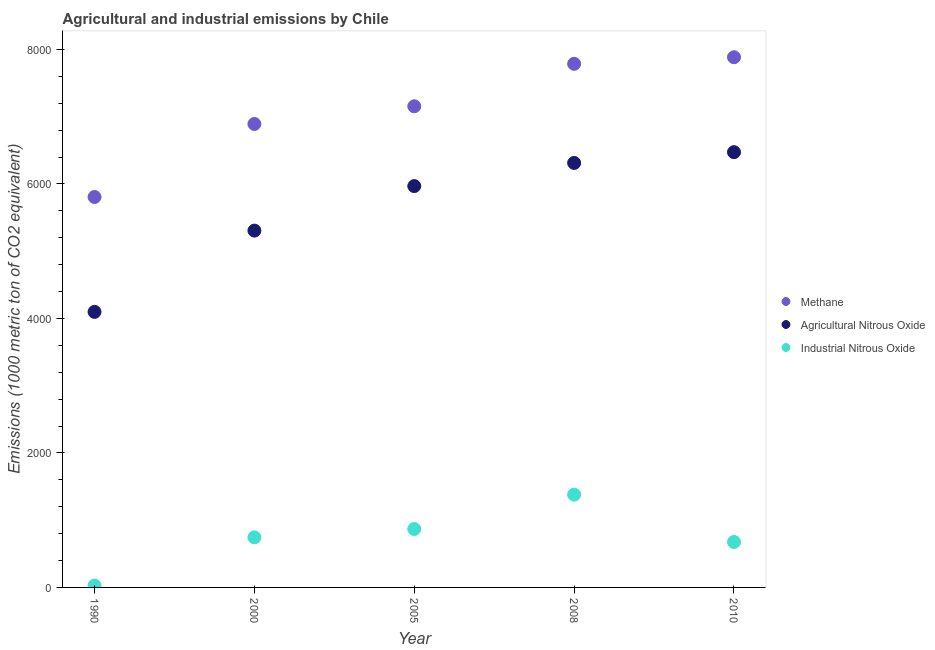What is the amount of agricultural nitrous oxide emissions in 1990?
Provide a short and direct response. 4097. Across all years, what is the maximum amount of methane emissions?
Provide a succinct answer. 7883.7. Across all years, what is the minimum amount of methane emissions?
Your answer should be compact. 5805.8. In which year was the amount of agricultural nitrous oxide emissions minimum?
Offer a very short reply. 1990. What is the total amount of industrial nitrous oxide emissions in the graph?
Ensure brevity in your answer.  3697.6. What is the difference between the amount of methane emissions in 1990 and that in 2005?
Keep it short and to the point. -1348.7. What is the difference between the amount of agricultural nitrous oxide emissions in 2010 and the amount of industrial nitrous oxide emissions in 2005?
Provide a short and direct response. 5603.4. What is the average amount of methane emissions per year?
Make the answer very short. 7104.34. In the year 2005, what is the difference between the amount of agricultural nitrous oxide emissions and amount of industrial nitrous oxide emissions?
Your answer should be very brief. 5099. What is the ratio of the amount of industrial nitrous oxide emissions in 1990 to that in 2008?
Your response must be concise. 0.02. Is the amount of methane emissions in 1990 less than that in 2010?
Your answer should be very brief. Yes. Is the difference between the amount of industrial nitrous oxide emissions in 2005 and 2008 greater than the difference between the amount of methane emissions in 2005 and 2008?
Make the answer very short. Yes. What is the difference between the highest and the second highest amount of industrial nitrous oxide emissions?
Make the answer very short. 510.9. What is the difference between the highest and the lowest amount of industrial nitrous oxide emissions?
Keep it short and to the point. 1351.8. In how many years, is the amount of methane emissions greater than the average amount of methane emissions taken over all years?
Offer a very short reply. 3. Is the sum of the amount of industrial nitrous oxide emissions in 1990 and 2008 greater than the maximum amount of agricultural nitrous oxide emissions across all years?
Your answer should be very brief. No. Is the amount of agricultural nitrous oxide emissions strictly greater than the amount of industrial nitrous oxide emissions over the years?
Your response must be concise. Yes. How many dotlines are there?
Offer a very short reply. 3. What is the difference between two consecutive major ticks on the Y-axis?
Offer a very short reply. 2000. Are the values on the major ticks of Y-axis written in scientific E-notation?
Offer a terse response. No. Does the graph contain any zero values?
Keep it short and to the point. No. How are the legend labels stacked?
Ensure brevity in your answer.  Vertical. What is the title of the graph?
Make the answer very short. Agricultural and industrial emissions by Chile. What is the label or title of the X-axis?
Provide a succinct answer. Year. What is the label or title of the Y-axis?
Provide a succinct answer. Emissions (1000 metric ton of CO2 equivalent). What is the Emissions (1000 metric ton of CO2 equivalent) in Methane in 1990?
Make the answer very short. 5805.8. What is the Emissions (1000 metric ton of CO2 equivalent) of Agricultural Nitrous Oxide in 1990?
Your response must be concise. 4097. What is the Emissions (1000 metric ton of CO2 equivalent) in Industrial Nitrous Oxide in 1990?
Your response must be concise. 27.9. What is the Emissions (1000 metric ton of CO2 equivalent) in Methane in 2000?
Offer a terse response. 6891.6. What is the Emissions (1000 metric ton of CO2 equivalent) of Agricultural Nitrous Oxide in 2000?
Provide a succinct answer. 5305.7. What is the Emissions (1000 metric ton of CO2 equivalent) in Industrial Nitrous Oxide in 2000?
Make the answer very short. 744.9. What is the Emissions (1000 metric ton of CO2 equivalent) of Methane in 2005?
Ensure brevity in your answer.  7154.5. What is the Emissions (1000 metric ton of CO2 equivalent) in Agricultural Nitrous Oxide in 2005?
Provide a short and direct response. 5967.8. What is the Emissions (1000 metric ton of CO2 equivalent) of Industrial Nitrous Oxide in 2005?
Make the answer very short. 868.8. What is the Emissions (1000 metric ton of CO2 equivalent) in Methane in 2008?
Your answer should be very brief. 7786.1. What is the Emissions (1000 metric ton of CO2 equivalent) of Agricultural Nitrous Oxide in 2008?
Provide a succinct answer. 6312. What is the Emissions (1000 metric ton of CO2 equivalent) in Industrial Nitrous Oxide in 2008?
Your answer should be very brief. 1379.7. What is the Emissions (1000 metric ton of CO2 equivalent) of Methane in 2010?
Provide a short and direct response. 7883.7. What is the Emissions (1000 metric ton of CO2 equivalent) of Agricultural Nitrous Oxide in 2010?
Make the answer very short. 6472.2. What is the Emissions (1000 metric ton of CO2 equivalent) in Industrial Nitrous Oxide in 2010?
Keep it short and to the point. 676.3. Across all years, what is the maximum Emissions (1000 metric ton of CO2 equivalent) in Methane?
Your response must be concise. 7883.7. Across all years, what is the maximum Emissions (1000 metric ton of CO2 equivalent) in Agricultural Nitrous Oxide?
Offer a very short reply. 6472.2. Across all years, what is the maximum Emissions (1000 metric ton of CO2 equivalent) of Industrial Nitrous Oxide?
Make the answer very short. 1379.7. Across all years, what is the minimum Emissions (1000 metric ton of CO2 equivalent) of Methane?
Keep it short and to the point. 5805.8. Across all years, what is the minimum Emissions (1000 metric ton of CO2 equivalent) in Agricultural Nitrous Oxide?
Keep it short and to the point. 4097. Across all years, what is the minimum Emissions (1000 metric ton of CO2 equivalent) in Industrial Nitrous Oxide?
Offer a terse response. 27.9. What is the total Emissions (1000 metric ton of CO2 equivalent) of Methane in the graph?
Make the answer very short. 3.55e+04. What is the total Emissions (1000 metric ton of CO2 equivalent) of Agricultural Nitrous Oxide in the graph?
Your answer should be compact. 2.82e+04. What is the total Emissions (1000 metric ton of CO2 equivalent) in Industrial Nitrous Oxide in the graph?
Provide a succinct answer. 3697.6. What is the difference between the Emissions (1000 metric ton of CO2 equivalent) of Methane in 1990 and that in 2000?
Ensure brevity in your answer.  -1085.8. What is the difference between the Emissions (1000 metric ton of CO2 equivalent) of Agricultural Nitrous Oxide in 1990 and that in 2000?
Provide a short and direct response. -1208.7. What is the difference between the Emissions (1000 metric ton of CO2 equivalent) in Industrial Nitrous Oxide in 1990 and that in 2000?
Your response must be concise. -717. What is the difference between the Emissions (1000 metric ton of CO2 equivalent) of Methane in 1990 and that in 2005?
Keep it short and to the point. -1348.7. What is the difference between the Emissions (1000 metric ton of CO2 equivalent) of Agricultural Nitrous Oxide in 1990 and that in 2005?
Give a very brief answer. -1870.8. What is the difference between the Emissions (1000 metric ton of CO2 equivalent) in Industrial Nitrous Oxide in 1990 and that in 2005?
Offer a very short reply. -840.9. What is the difference between the Emissions (1000 metric ton of CO2 equivalent) of Methane in 1990 and that in 2008?
Your answer should be compact. -1980.3. What is the difference between the Emissions (1000 metric ton of CO2 equivalent) of Agricultural Nitrous Oxide in 1990 and that in 2008?
Your answer should be very brief. -2215. What is the difference between the Emissions (1000 metric ton of CO2 equivalent) of Industrial Nitrous Oxide in 1990 and that in 2008?
Offer a terse response. -1351.8. What is the difference between the Emissions (1000 metric ton of CO2 equivalent) in Methane in 1990 and that in 2010?
Your answer should be very brief. -2077.9. What is the difference between the Emissions (1000 metric ton of CO2 equivalent) of Agricultural Nitrous Oxide in 1990 and that in 2010?
Keep it short and to the point. -2375.2. What is the difference between the Emissions (1000 metric ton of CO2 equivalent) of Industrial Nitrous Oxide in 1990 and that in 2010?
Make the answer very short. -648.4. What is the difference between the Emissions (1000 metric ton of CO2 equivalent) in Methane in 2000 and that in 2005?
Offer a very short reply. -262.9. What is the difference between the Emissions (1000 metric ton of CO2 equivalent) in Agricultural Nitrous Oxide in 2000 and that in 2005?
Make the answer very short. -662.1. What is the difference between the Emissions (1000 metric ton of CO2 equivalent) of Industrial Nitrous Oxide in 2000 and that in 2005?
Give a very brief answer. -123.9. What is the difference between the Emissions (1000 metric ton of CO2 equivalent) in Methane in 2000 and that in 2008?
Keep it short and to the point. -894.5. What is the difference between the Emissions (1000 metric ton of CO2 equivalent) of Agricultural Nitrous Oxide in 2000 and that in 2008?
Provide a short and direct response. -1006.3. What is the difference between the Emissions (1000 metric ton of CO2 equivalent) of Industrial Nitrous Oxide in 2000 and that in 2008?
Your response must be concise. -634.8. What is the difference between the Emissions (1000 metric ton of CO2 equivalent) of Methane in 2000 and that in 2010?
Offer a terse response. -992.1. What is the difference between the Emissions (1000 metric ton of CO2 equivalent) of Agricultural Nitrous Oxide in 2000 and that in 2010?
Keep it short and to the point. -1166.5. What is the difference between the Emissions (1000 metric ton of CO2 equivalent) of Industrial Nitrous Oxide in 2000 and that in 2010?
Ensure brevity in your answer.  68.6. What is the difference between the Emissions (1000 metric ton of CO2 equivalent) in Methane in 2005 and that in 2008?
Your answer should be very brief. -631.6. What is the difference between the Emissions (1000 metric ton of CO2 equivalent) in Agricultural Nitrous Oxide in 2005 and that in 2008?
Your answer should be very brief. -344.2. What is the difference between the Emissions (1000 metric ton of CO2 equivalent) of Industrial Nitrous Oxide in 2005 and that in 2008?
Your answer should be very brief. -510.9. What is the difference between the Emissions (1000 metric ton of CO2 equivalent) in Methane in 2005 and that in 2010?
Your answer should be very brief. -729.2. What is the difference between the Emissions (1000 metric ton of CO2 equivalent) of Agricultural Nitrous Oxide in 2005 and that in 2010?
Make the answer very short. -504.4. What is the difference between the Emissions (1000 metric ton of CO2 equivalent) in Industrial Nitrous Oxide in 2005 and that in 2010?
Give a very brief answer. 192.5. What is the difference between the Emissions (1000 metric ton of CO2 equivalent) of Methane in 2008 and that in 2010?
Offer a terse response. -97.6. What is the difference between the Emissions (1000 metric ton of CO2 equivalent) in Agricultural Nitrous Oxide in 2008 and that in 2010?
Ensure brevity in your answer.  -160.2. What is the difference between the Emissions (1000 metric ton of CO2 equivalent) in Industrial Nitrous Oxide in 2008 and that in 2010?
Your answer should be compact. 703.4. What is the difference between the Emissions (1000 metric ton of CO2 equivalent) in Methane in 1990 and the Emissions (1000 metric ton of CO2 equivalent) in Agricultural Nitrous Oxide in 2000?
Give a very brief answer. 500.1. What is the difference between the Emissions (1000 metric ton of CO2 equivalent) of Methane in 1990 and the Emissions (1000 metric ton of CO2 equivalent) of Industrial Nitrous Oxide in 2000?
Keep it short and to the point. 5060.9. What is the difference between the Emissions (1000 metric ton of CO2 equivalent) in Agricultural Nitrous Oxide in 1990 and the Emissions (1000 metric ton of CO2 equivalent) in Industrial Nitrous Oxide in 2000?
Provide a short and direct response. 3352.1. What is the difference between the Emissions (1000 metric ton of CO2 equivalent) in Methane in 1990 and the Emissions (1000 metric ton of CO2 equivalent) in Agricultural Nitrous Oxide in 2005?
Keep it short and to the point. -162. What is the difference between the Emissions (1000 metric ton of CO2 equivalent) in Methane in 1990 and the Emissions (1000 metric ton of CO2 equivalent) in Industrial Nitrous Oxide in 2005?
Make the answer very short. 4937. What is the difference between the Emissions (1000 metric ton of CO2 equivalent) in Agricultural Nitrous Oxide in 1990 and the Emissions (1000 metric ton of CO2 equivalent) in Industrial Nitrous Oxide in 2005?
Make the answer very short. 3228.2. What is the difference between the Emissions (1000 metric ton of CO2 equivalent) in Methane in 1990 and the Emissions (1000 metric ton of CO2 equivalent) in Agricultural Nitrous Oxide in 2008?
Offer a terse response. -506.2. What is the difference between the Emissions (1000 metric ton of CO2 equivalent) of Methane in 1990 and the Emissions (1000 metric ton of CO2 equivalent) of Industrial Nitrous Oxide in 2008?
Provide a succinct answer. 4426.1. What is the difference between the Emissions (1000 metric ton of CO2 equivalent) in Agricultural Nitrous Oxide in 1990 and the Emissions (1000 metric ton of CO2 equivalent) in Industrial Nitrous Oxide in 2008?
Make the answer very short. 2717.3. What is the difference between the Emissions (1000 metric ton of CO2 equivalent) of Methane in 1990 and the Emissions (1000 metric ton of CO2 equivalent) of Agricultural Nitrous Oxide in 2010?
Ensure brevity in your answer.  -666.4. What is the difference between the Emissions (1000 metric ton of CO2 equivalent) of Methane in 1990 and the Emissions (1000 metric ton of CO2 equivalent) of Industrial Nitrous Oxide in 2010?
Give a very brief answer. 5129.5. What is the difference between the Emissions (1000 metric ton of CO2 equivalent) in Agricultural Nitrous Oxide in 1990 and the Emissions (1000 metric ton of CO2 equivalent) in Industrial Nitrous Oxide in 2010?
Provide a short and direct response. 3420.7. What is the difference between the Emissions (1000 metric ton of CO2 equivalent) of Methane in 2000 and the Emissions (1000 metric ton of CO2 equivalent) of Agricultural Nitrous Oxide in 2005?
Provide a succinct answer. 923.8. What is the difference between the Emissions (1000 metric ton of CO2 equivalent) of Methane in 2000 and the Emissions (1000 metric ton of CO2 equivalent) of Industrial Nitrous Oxide in 2005?
Make the answer very short. 6022.8. What is the difference between the Emissions (1000 metric ton of CO2 equivalent) in Agricultural Nitrous Oxide in 2000 and the Emissions (1000 metric ton of CO2 equivalent) in Industrial Nitrous Oxide in 2005?
Your answer should be compact. 4436.9. What is the difference between the Emissions (1000 metric ton of CO2 equivalent) in Methane in 2000 and the Emissions (1000 metric ton of CO2 equivalent) in Agricultural Nitrous Oxide in 2008?
Offer a terse response. 579.6. What is the difference between the Emissions (1000 metric ton of CO2 equivalent) of Methane in 2000 and the Emissions (1000 metric ton of CO2 equivalent) of Industrial Nitrous Oxide in 2008?
Offer a very short reply. 5511.9. What is the difference between the Emissions (1000 metric ton of CO2 equivalent) in Agricultural Nitrous Oxide in 2000 and the Emissions (1000 metric ton of CO2 equivalent) in Industrial Nitrous Oxide in 2008?
Your response must be concise. 3926. What is the difference between the Emissions (1000 metric ton of CO2 equivalent) of Methane in 2000 and the Emissions (1000 metric ton of CO2 equivalent) of Agricultural Nitrous Oxide in 2010?
Give a very brief answer. 419.4. What is the difference between the Emissions (1000 metric ton of CO2 equivalent) in Methane in 2000 and the Emissions (1000 metric ton of CO2 equivalent) in Industrial Nitrous Oxide in 2010?
Give a very brief answer. 6215.3. What is the difference between the Emissions (1000 metric ton of CO2 equivalent) in Agricultural Nitrous Oxide in 2000 and the Emissions (1000 metric ton of CO2 equivalent) in Industrial Nitrous Oxide in 2010?
Keep it short and to the point. 4629.4. What is the difference between the Emissions (1000 metric ton of CO2 equivalent) of Methane in 2005 and the Emissions (1000 metric ton of CO2 equivalent) of Agricultural Nitrous Oxide in 2008?
Keep it short and to the point. 842.5. What is the difference between the Emissions (1000 metric ton of CO2 equivalent) in Methane in 2005 and the Emissions (1000 metric ton of CO2 equivalent) in Industrial Nitrous Oxide in 2008?
Provide a short and direct response. 5774.8. What is the difference between the Emissions (1000 metric ton of CO2 equivalent) in Agricultural Nitrous Oxide in 2005 and the Emissions (1000 metric ton of CO2 equivalent) in Industrial Nitrous Oxide in 2008?
Offer a terse response. 4588.1. What is the difference between the Emissions (1000 metric ton of CO2 equivalent) in Methane in 2005 and the Emissions (1000 metric ton of CO2 equivalent) in Agricultural Nitrous Oxide in 2010?
Provide a short and direct response. 682.3. What is the difference between the Emissions (1000 metric ton of CO2 equivalent) in Methane in 2005 and the Emissions (1000 metric ton of CO2 equivalent) in Industrial Nitrous Oxide in 2010?
Your answer should be compact. 6478.2. What is the difference between the Emissions (1000 metric ton of CO2 equivalent) of Agricultural Nitrous Oxide in 2005 and the Emissions (1000 metric ton of CO2 equivalent) of Industrial Nitrous Oxide in 2010?
Make the answer very short. 5291.5. What is the difference between the Emissions (1000 metric ton of CO2 equivalent) in Methane in 2008 and the Emissions (1000 metric ton of CO2 equivalent) in Agricultural Nitrous Oxide in 2010?
Keep it short and to the point. 1313.9. What is the difference between the Emissions (1000 metric ton of CO2 equivalent) in Methane in 2008 and the Emissions (1000 metric ton of CO2 equivalent) in Industrial Nitrous Oxide in 2010?
Your response must be concise. 7109.8. What is the difference between the Emissions (1000 metric ton of CO2 equivalent) of Agricultural Nitrous Oxide in 2008 and the Emissions (1000 metric ton of CO2 equivalent) of Industrial Nitrous Oxide in 2010?
Provide a succinct answer. 5635.7. What is the average Emissions (1000 metric ton of CO2 equivalent) in Methane per year?
Your response must be concise. 7104.34. What is the average Emissions (1000 metric ton of CO2 equivalent) of Agricultural Nitrous Oxide per year?
Give a very brief answer. 5630.94. What is the average Emissions (1000 metric ton of CO2 equivalent) in Industrial Nitrous Oxide per year?
Your answer should be compact. 739.52. In the year 1990, what is the difference between the Emissions (1000 metric ton of CO2 equivalent) in Methane and Emissions (1000 metric ton of CO2 equivalent) in Agricultural Nitrous Oxide?
Make the answer very short. 1708.8. In the year 1990, what is the difference between the Emissions (1000 metric ton of CO2 equivalent) of Methane and Emissions (1000 metric ton of CO2 equivalent) of Industrial Nitrous Oxide?
Your response must be concise. 5777.9. In the year 1990, what is the difference between the Emissions (1000 metric ton of CO2 equivalent) of Agricultural Nitrous Oxide and Emissions (1000 metric ton of CO2 equivalent) of Industrial Nitrous Oxide?
Keep it short and to the point. 4069.1. In the year 2000, what is the difference between the Emissions (1000 metric ton of CO2 equivalent) of Methane and Emissions (1000 metric ton of CO2 equivalent) of Agricultural Nitrous Oxide?
Your answer should be very brief. 1585.9. In the year 2000, what is the difference between the Emissions (1000 metric ton of CO2 equivalent) of Methane and Emissions (1000 metric ton of CO2 equivalent) of Industrial Nitrous Oxide?
Ensure brevity in your answer.  6146.7. In the year 2000, what is the difference between the Emissions (1000 metric ton of CO2 equivalent) in Agricultural Nitrous Oxide and Emissions (1000 metric ton of CO2 equivalent) in Industrial Nitrous Oxide?
Your response must be concise. 4560.8. In the year 2005, what is the difference between the Emissions (1000 metric ton of CO2 equivalent) of Methane and Emissions (1000 metric ton of CO2 equivalent) of Agricultural Nitrous Oxide?
Give a very brief answer. 1186.7. In the year 2005, what is the difference between the Emissions (1000 metric ton of CO2 equivalent) in Methane and Emissions (1000 metric ton of CO2 equivalent) in Industrial Nitrous Oxide?
Your answer should be compact. 6285.7. In the year 2005, what is the difference between the Emissions (1000 metric ton of CO2 equivalent) of Agricultural Nitrous Oxide and Emissions (1000 metric ton of CO2 equivalent) of Industrial Nitrous Oxide?
Keep it short and to the point. 5099. In the year 2008, what is the difference between the Emissions (1000 metric ton of CO2 equivalent) of Methane and Emissions (1000 metric ton of CO2 equivalent) of Agricultural Nitrous Oxide?
Provide a succinct answer. 1474.1. In the year 2008, what is the difference between the Emissions (1000 metric ton of CO2 equivalent) in Methane and Emissions (1000 metric ton of CO2 equivalent) in Industrial Nitrous Oxide?
Your answer should be very brief. 6406.4. In the year 2008, what is the difference between the Emissions (1000 metric ton of CO2 equivalent) in Agricultural Nitrous Oxide and Emissions (1000 metric ton of CO2 equivalent) in Industrial Nitrous Oxide?
Offer a terse response. 4932.3. In the year 2010, what is the difference between the Emissions (1000 metric ton of CO2 equivalent) of Methane and Emissions (1000 metric ton of CO2 equivalent) of Agricultural Nitrous Oxide?
Offer a very short reply. 1411.5. In the year 2010, what is the difference between the Emissions (1000 metric ton of CO2 equivalent) of Methane and Emissions (1000 metric ton of CO2 equivalent) of Industrial Nitrous Oxide?
Your response must be concise. 7207.4. In the year 2010, what is the difference between the Emissions (1000 metric ton of CO2 equivalent) of Agricultural Nitrous Oxide and Emissions (1000 metric ton of CO2 equivalent) of Industrial Nitrous Oxide?
Provide a succinct answer. 5795.9. What is the ratio of the Emissions (1000 metric ton of CO2 equivalent) in Methane in 1990 to that in 2000?
Provide a short and direct response. 0.84. What is the ratio of the Emissions (1000 metric ton of CO2 equivalent) in Agricultural Nitrous Oxide in 1990 to that in 2000?
Your response must be concise. 0.77. What is the ratio of the Emissions (1000 metric ton of CO2 equivalent) in Industrial Nitrous Oxide in 1990 to that in 2000?
Provide a succinct answer. 0.04. What is the ratio of the Emissions (1000 metric ton of CO2 equivalent) in Methane in 1990 to that in 2005?
Your answer should be compact. 0.81. What is the ratio of the Emissions (1000 metric ton of CO2 equivalent) in Agricultural Nitrous Oxide in 1990 to that in 2005?
Ensure brevity in your answer.  0.69. What is the ratio of the Emissions (1000 metric ton of CO2 equivalent) in Industrial Nitrous Oxide in 1990 to that in 2005?
Your response must be concise. 0.03. What is the ratio of the Emissions (1000 metric ton of CO2 equivalent) of Methane in 1990 to that in 2008?
Provide a short and direct response. 0.75. What is the ratio of the Emissions (1000 metric ton of CO2 equivalent) in Agricultural Nitrous Oxide in 1990 to that in 2008?
Give a very brief answer. 0.65. What is the ratio of the Emissions (1000 metric ton of CO2 equivalent) of Industrial Nitrous Oxide in 1990 to that in 2008?
Make the answer very short. 0.02. What is the ratio of the Emissions (1000 metric ton of CO2 equivalent) of Methane in 1990 to that in 2010?
Provide a short and direct response. 0.74. What is the ratio of the Emissions (1000 metric ton of CO2 equivalent) in Agricultural Nitrous Oxide in 1990 to that in 2010?
Give a very brief answer. 0.63. What is the ratio of the Emissions (1000 metric ton of CO2 equivalent) of Industrial Nitrous Oxide in 1990 to that in 2010?
Provide a short and direct response. 0.04. What is the ratio of the Emissions (1000 metric ton of CO2 equivalent) in Methane in 2000 to that in 2005?
Your answer should be compact. 0.96. What is the ratio of the Emissions (1000 metric ton of CO2 equivalent) in Agricultural Nitrous Oxide in 2000 to that in 2005?
Ensure brevity in your answer.  0.89. What is the ratio of the Emissions (1000 metric ton of CO2 equivalent) in Industrial Nitrous Oxide in 2000 to that in 2005?
Offer a terse response. 0.86. What is the ratio of the Emissions (1000 metric ton of CO2 equivalent) in Methane in 2000 to that in 2008?
Your answer should be compact. 0.89. What is the ratio of the Emissions (1000 metric ton of CO2 equivalent) in Agricultural Nitrous Oxide in 2000 to that in 2008?
Provide a short and direct response. 0.84. What is the ratio of the Emissions (1000 metric ton of CO2 equivalent) in Industrial Nitrous Oxide in 2000 to that in 2008?
Give a very brief answer. 0.54. What is the ratio of the Emissions (1000 metric ton of CO2 equivalent) in Methane in 2000 to that in 2010?
Ensure brevity in your answer.  0.87. What is the ratio of the Emissions (1000 metric ton of CO2 equivalent) in Agricultural Nitrous Oxide in 2000 to that in 2010?
Your answer should be compact. 0.82. What is the ratio of the Emissions (1000 metric ton of CO2 equivalent) in Industrial Nitrous Oxide in 2000 to that in 2010?
Your answer should be compact. 1.1. What is the ratio of the Emissions (1000 metric ton of CO2 equivalent) of Methane in 2005 to that in 2008?
Your answer should be compact. 0.92. What is the ratio of the Emissions (1000 metric ton of CO2 equivalent) of Agricultural Nitrous Oxide in 2005 to that in 2008?
Ensure brevity in your answer.  0.95. What is the ratio of the Emissions (1000 metric ton of CO2 equivalent) in Industrial Nitrous Oxide in 2005 to that in 2008?
Your response must be concise. 0.63. What is the ratio of the Emissions (1000 metric ton of CO2 equivalent) in Methane in 2005 to that in 2010?
Your answer should be compact. 0.91. What is the ratio of the Emissions (1000 metric ton of CO2 equivalent) in Agricultural Nitrous Oxide in 2005 to that in 2010?
Your answer should be very brief. 0.92. What is the ratio of the Emissions (1000 metric ton of CO2 equivalent) of Industrial Nitrous Oxide in 2005 to that in 2010?
Ensure brevity in your answer.  1.28. What is the ratio of the Emissions (1000 metric ton of CO2 equivalent) in Methane in 2008 to that in 2010?
Keep it short and to the point. 0.99. What is the ratio of the Emissions (1000 metric ton of CO2 equivalent) of Agricultural Nitrous Oxide in 2008 to that in 2010?
Your answer should be very brief. 0.98. What is the ratio of the Emissions (1000 metric ton of CO2 equivalent) in Industrial Nitrous Oxide in 2008 to that in 2010?
Make the answer very short. 2.04. What is the difference between the highest and the second highest Emissions (1000 metric ton of CO2 equivalent) of Methane?
Give a very brief answer. 97.6. What is the difference between the highest and the second highest Emissions (1000 metric ton of CO2 equivalent) of Agricultural Nitrous Oxide?
Provide a succinct answer. 160.2. What is the difference between the highest and the second highest Emissions (1000 metric ton of CO2 equivalent) of Industrial Nitrous Oxide?
Your response must be concise. 510.9. What is the difference between the highest and the lowest Emissions (1000 metric ton of CO2 equivalent) in Methane?
Provide a succinct answer. 2077.9. What is the difference between the highest and the lowest Emissions (1000 metric ton of CO2 equivalent) of Agricultural Nitrous Oxide?
Ensure brevity in your answer.  2375.2. What is the difference between the highest and the lowest Emissions (1000 metric ton of CO2 equivalent) of Industrial Nitrous Oxide?
Give a very brief answer. 1351.8. 